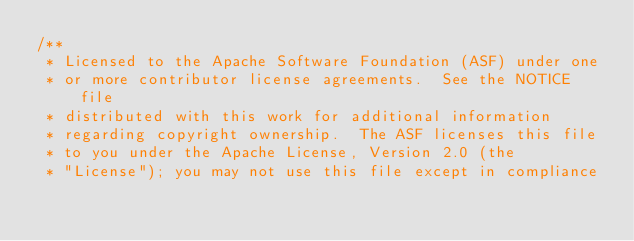Convert code to text. <code><loc_0><loc_0><loc_500><loc_500><_Java_>/**
 * Licensed to the Apache Software Foundation (ASF) under one
 * or more contributor license agreements.  See the NOTICE file
 * distributed with this work for additional information
 * regarding copyright ownership.  The ASF licenses this file
 * to you under the Apache License, Version 2.0 (the
 * "License"); you may not use this file except in compliance</code> 